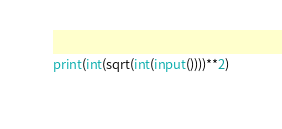Convert code to text. <code><loc_0><loc_0><loc_500><loc_500><_Python_>print(int(sqrt(int(input())))**2)</code> 